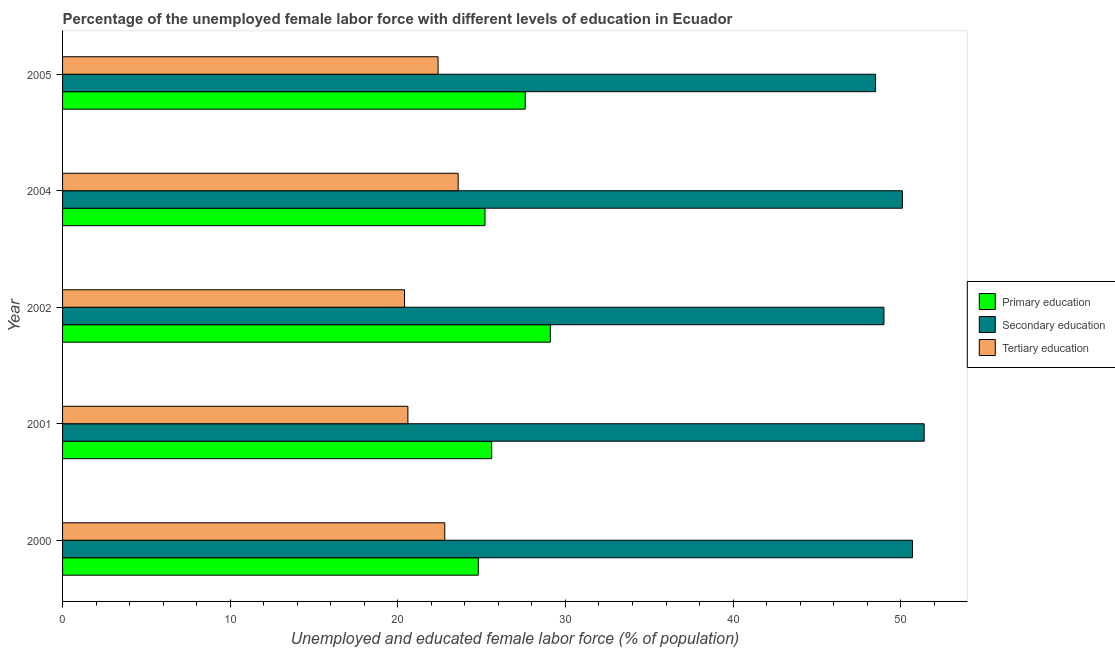How many groups of bars are there?
Offer a terse response. 5. Are the number of bars on each tick of the Y-axis equal?
Make the answer very short. Yes. What is the label of the 4th group of bars from the top?
Make the answer very short. 2001. What is the percentage of female labor force who received secondary education in 2005?
Offer a terse response. 48.5. Across all years, what is the maximum percentage of female labor force who received secondary education?
Give a very brief answer. 51.4. Across all years, what is the minimum percentage of female labor force who received primary education?
Keep it short and to the point. 24.8. In which year was the percentage of female labor force who received tertiary education minimum?
Give a very brief answer. 2002. What is the total percentage of female labor force who received primary education in the graph?
Provide a succinct answer. 132.3. What is the difference between the percentage of female labor force who received tertiary education in 2000 and the percentage of female labor force who received secondary education in 2005?
Offer a very short reply. -25.7. What is the average percentage of female labor force who received primary education per year?
Give a very brief answer. 26.46. In how many years, is the percentage of female labor force who received tertiary education greater than 28 %?
Your answer should be compact. 0. Is the percentage of female labor force who received tertiary education in 2000 less than that in 2002?
Offer a terse response. No. What is the difference between the highest and the second highest percentage of female labor force who received tertiary education?
Offer a terse response. 0.8. What is the difference between the highest and the lowest percentage of female labor force who received primary education?
Give a very brief answer. 4.3. Is the sum of the percentage of female labor force who received primary education in 2001 and 2005 greater than the maximum percentage of female labor force who received tertiary education across all years?
Offer a very short reply. Yes. What does the 3rd bar from the top in 2001 represents?
Keep it short and to the point. Primary education. What does the 2nd bar from the bottom in 2002 represents?
Your response must be concise. Secondary education. How many years are there in the graph?
Give a very brief answer. 5. What is the difference between two consecutive major ticks on the X-axis?
Offer a very short reply. 10. Are the values on the major ticks of X-axis written in scientific E-notation?
Your answer should be very brief. No. Does the graph contain any zero values?
Your answer should be compact. No. How are the legend labels stacked?
Your response must be concise. Vertical. What is the title of the graph?
Make the answer very short. Percentage of the unemployed female labor force with different levels of education in Ecuador. What is the label or title of the X-axis?
Give a very brief answer. Unemployed and educated female labor force (% of population). What is the Unemployed and educated female labor force (% of population) of Primary education in 2000?
Your response must be concise. 24.8. What is the Unemployed and educated female labor force (% of population) of Secondary education in 2000?
Make the answer very short. 50.7. What is the Unemployed and educated female labor force (% of population) of Tertiary education in 2000?
Give a very brief answer. 22.8. What is the Unemployed and educated female labor force (% of population) in Primary education in 2001?
Keep it short and to the point. 25.6. What is the Unemployed and educated female labor force (% of population) in Secondary education in 2001?
Give a very brief answer. 51.4. What is the Unemployed and educated female labor force (% of population) of Tertiary education in 2001?
Make the answer very short. 20.6. What is the Unemployed and educated female labor force (% of population) of Primary education in 2002?
Ensure brevity in your answer.  29.1. What is the Unemployed and educated female labor force (% of population) in Secondary education in 2002?
Provide a short and direct response. 49. What is the Unemployed and educated female labor force (% of population) of Tertiary education in 2002?
Provide a succinct answer. 20.4. What is the Unemployed and educated female labor force (% of population) of Primary education in 2004?
Your answer should be compact. 25.2. What is the Unemployed and educated female labor force (% of population) of Secondary education in 2004?
Your answer should be very brief. 50.1. What is the Unemployed and educated female labor force (% of population) of Tertiary education in 2004?
Make the answer very short. 23.6. What is the Unemployed and educated female labor force (% of population) of Primary education in 2005?
Offer a terse response. 27.6. What is the Unemployed and educated female labor force (% of population) in Secondary education in 2005?
Your answer should be compact. 48.5. What is the Unemployed and educated female labor force (% of population) in Tertiary education in 2005?
Provide a short and direct response. 22.4. Across all years, what is the maximum Unemployed and educated female labor force (% of population) in Primary education?
Keep it short and to the point. 29.1. Across all years, what is the maximum Unemployed and educated female labor force (% of population) in Secondary education?
Provide a short and direct response. 51.4. Across all years, what is the maximum Unemployed and educated female labor force (% of population) in Tertiary education?
Your response must be concise. 23.6. Across all years, what is the minimum Unemployed and educated female labor force (% of population) in Primary education?
Make the answer very short. 24.8. Across all years, what is the minimum Unemployed and educated female labor force (% of population) in Secondary education?
Provide a short and direct response. 48.5. Across all years, what is the minimum Unemployed and educated female labor force (% of population) of Tertiary education?
Your response must be concise. 20.4. What is the total Unemployed and educated female labor force (% of population) of Primary education in the graph?
Your answer should be very brief. 132.3. What is the total Unemployed and educated female labor force (% of population) of Secondary education in the graph?
Make the answer very short. 249.7. What is the total Unemployed and educated female labor force (% of population) of Tertiary education in the graph?
Offer a terse response. 109.8. What is the difference between the Unemployed and educated female labor force (% of population) in Primary education in 2000 and that in 2001?
Your answer should be compact. -0.8. What is the difference between the Unemployed and educated female labor force (% of population) of Tertiary education in 2000 and that in 2001?
Keep it short and to the point. 2.2. What is the difference between the Unemployed and educated female labor force (% of population) of Primary education in 2000 and that in 2002?
Your response must be concise. -4.3. What is the difference between the Unemployed and educated female labor force (% of population) of Secondary education in 2000 and that in 2004?
Give a very brief answer. 0.6. What is the difference between the Unemployed and educated female labor force (% of population) in Primary education in 2000 and that in 2005?
Give a very brief answer. -2.8. What is the difference between the Unemployed and educated female labor force (% of population) of Secondary education in 2000 and that in 2005?
Offer a terse response. 2.2. What is the difference between the Unemployed and educated female labor force (% of population) in Primary education in 2001 and that in 2002?
Offer a very short reply. -3.5. What is the difference between the Unemployed and educated female labor force (% of population) in Secondary education in 2001 and that in 2002?
Give a very brief answer. 2.4. What is the difference between the Unemployed and educated female labor force (% of population) of Tertiary education in 2001 and that in 2002?
Ensure brevity in your answer.  0.2. What is the difference between the Unemployed and educated female labor force (% of population) of Primary education in 2001 and that in 2004?
Your answer should be very brief. 0.4. What is the difference between the Unemployed and educated female labor force (% of population) in Secondary education in 2001 and that in 2004?
Provide a short and direct response. 1.3. What is the difference between the Unemployed and educated female labor force (% of population) in Primary education in 2001 and that in 2005?
Keep it short and to the point. -2. What is the difference between the Unemployed and educated female labor force (% of population) in Secondary education in 2001 and that in 2005?
Keep it short and to the point. 2.9. What is the difference between the Unemployed and educated female labor force (% of population) of Primary education in 2002 and that in 2004?
Your answer should be compact. 3.9. What is the difference between the Unemployed and educated female labor force (% of population) in Primary education in 2002 and that in 2005?
Provide a short and direct response. 1.5. What is the difference between the Unemployed and educated female labor force (% of population) of Secondary education in 2002 and that in 2005?
Give a very brief answer. 0.5. What is the difference between the Unemployed and educated female labor force (% of population) of Tertiary education in 2002 and that in 2005?
Offer a very short reply. -2. What is the difference between the Unemployed and educated female labor force (% of population) in Tertiary education in 2004 and that in 2005?
Give a very brief answer. 1.2. What is the difference between the Unemployed and educated female labor force (% of population) in Primary education in 2000 and the Unemployed and educated female labor force (% of population) in Secondary education in 2001?
Your answer should be very brief. -26.6. What is the difference between the Unemployed and educated female labor force (% of population) of Secondary education in 2000 and the Unemployed and educated female labor force (% of population) of Tertiary education in 2001?
Give a very brief answer. 30.1. What is the difference between the Unemployed and educated female labor force (% of population) in Primary education in 2000 and the Unemployed and educated female labor force (% of population) in Secondary education in 2002?
Your response must be concise. -24.2. What is the difference between the Unemployed and educated female labor force (% of population) in Primary education in 2000 and the Unemployed and educated female labor force (% of population) in Tertiary education in 2002?
Provide a succinct answer. 4.4. What is the difference between the Unemployed and educated female labor force (% of population) in Secondary education in 2000 and the Unemployed and educated female labor force (% of population) in Tertiary education in 2002?
Offer a very short reply. 30.3. What is the difference between the Unemployed and educated female labor force (% of population) in Primary education in 2000 and the Unemployed and educated female labor force (% of population) in Secondary education in 2004?
Offer a terse response. -25.3. What is the difference between the Unemployed and educated female labor force (% of population) in Secondary education in 2000 and the Unemployed and educated female labor force (% of population) in Tertiary education in 2004?
Your answer should be very brief. 27.1. What is the difference between the Unemployed and educated female labor force (% of population) of Primary education in 2000 and the Unemployed and educated female labor force (% of population) of Secondary education in 2005?
Offer a very short reply. -23.7. What is the difference between the Unemployed and educated female labor force (% of population) of Primary education in 2000 and the Unemployed and educated female labor force (% of population) of Tertiary education in 2005?
Give a very brief answer. 2.4. What is the difference between the Unemployed and educated female labor force (% of population) of Secondary education in 2000 and the Unemployed and educated female labor force (% of population) of Tertiary education in 2005?
Your answer should be compact. 28.3. What is the difference between the Unemployed and educated female labor force (% of population) in Primary education in 2001 and the Unemployed and educated female labor force (% of population) in Secondary education in 2002?
Provide a succinct answer. -23.4. What is the difference between the Unemployed and educated female labor force (% of population) of Primary education in 2001 and the Unemployed and educated female labor force (% of population) of Secondary education in 2004?
Keep it short and to the point. -24.5. What is the difference between the Unemployed and educated female labor force (% of population) in Secondary education in 2001 and the Unemployed and educated female labor force (% of population) in Tertiary education in 2004?
Your answer should be compact. 27.8. What is the difference between the Unemployed and educated female labor force (% of population) of Primary education in 2001 and the Unemployed and educated female labor force (% of population) of Secondary education in 2005?
Keep it short and to the point. -22.9. What is the difference between the Unemployed and educated female labor force (% of population) in Secondary education in 2001 and the Unemployed and educated female labor force (% of population) in Tertiary education in 2005?
Ensure brevity in your answer.  29. What is the difference between the Unemployed and educated female labor force (% of population) of Primary education in 2002 and the Unemployed and educated female labor force (% of population) of Secondary education in 2004?
Your response must be concise. -21. What is the difference between the Unemployed and educated female labor force (% of population) of Primary education in 2002 and the Unemployed and educated female labor force (% of population) of Tertiary education in 2004?
Your answer should be very brief. 5.5. What is the difference between the Unemployed and educated female labor force (% of population) in Secondary education in 2002 and the Unemployed and educated female labor force (% of population) in Tertiary education in 2004?
Offer a very short reply. 25.4. What is the difference between the Unemployed and educated female labor force (% of population) in Primary education in 2002 and the Unemployed and educated female labor force (% of population) in Secondary education in 2005?
Keep it short and to the point. -19.4. What is the difference between the Unemployed and educated female labor force (% of population) of Primary education in 2002 and the Unemployed and educated female labor force (% of population) of Tertiary education in 2005?
Provide a short and direct response. 6.7. What is the difference between the Unemployed and educated female labor force (% of population) of Secondary education in 2002 and the Unemployed and educated female labor force (% of population) of Tertiary education in 2005?
Your answer should be very brief. 26.6. What is the difference between the Unemployed and educated female labor force (% of population) in Primary education in 2004 and the Unemployed and educated female labor force (% of population) in Secondary education in 2005?
Provide a succinct answer. -23.3. What is the difference between the Unemployed and educated female labor force (% of population) of Primary education in 2004 and the Unemployed and educated female labor force (% of population) of Tertiary education in 2005?
Offer a terse response. 2.8. What is the difference between the Unemployed and educated female labor force (% of population) in Secondary education in 2004 and the Unemployed and educated female labor force (% of population) in Tertiary education in 2005?
Make the answer very short. 27.7. What is the average Unemployed and educated female labor force (% of population) of Primary education per year?
Your answer should be compact. 26.46. What is the average Unemployed and educated female labor force (% of population) in Secondary education per year?
Offer a very short reply. 49.94. What is the average Unemployed and educated female labor force (% of population) in Tertiary education per year?
Provide a short and direct response. 21.96. In the year 2000, what is the difference between the Unemployed and educated female labor force (% of population) in Primary education and Unemployed and educated female labor force (% of population) in Secondary education?
Your answer should be compact. -25.9. In the year 2000, what is the difference between the Unemployed and educated female labor force (% of population) of Secondary education and Unemployed and educated female labor force (% of population) of Tertiary education?
Provide a succinct answer. 27.9. In the year 2001, what is the difference between the Unemployed and educated female labor force (% of population) in Primary education and Unemployed and educated female labor force (% of population) in Secondary education?
Provide a short and direct response. -25.8. In the year 2001, what is the difference between the Unemployed and educated female labor force (% of population) in Secondary education and Unemployed and educated female labor force (% of population) in Tertiary education?
Your answer should be compact. 30.8. In the year 2002, what is the difference between the Unemployed and educated female labor force (% of population) in Primary education and Unemployed and educated female labor force (% of population) in Secondary education?
Your answer should be very brief. -19.9. In the year 2002, what is the difference between the Unemployed and educated female labor force (% of population) in Primary education and Unemployed and educated female labor force (% of population) in Tertiary education?
Keep it short and to the point. 8.7. In the year 2002, what is the difference between the Unemployed and educated female labor force (% of population) of Secondary education and Unemployed and educated female labor force (% of population) of Tertiary education?
Provide a succinct answer. 28.6. In the year 2004, what is the difference between the Unemployed and educated female labor force (% of population) in Primary education and Unemployed and educated female labor force (% of population) in Secondary education?
Ensure brevity in your answer.  -24.9. In the year 2004, what is the difference between the Unemployed and educated female labor force (% of population) in Primary education and Unemployed and educated female labor force (% of population) in Tertiary education?
Your answer should be compact. 1.6. In the year 2005, what is the difference between the Unemployed and educated female labor force (% of population) of Primary education and Unemployed and educated female labor force (% of population) of Secondary education?
Give a very brief answer. -20.9. In the year 2005, what is the difference between the Unemployed and educated female labor force (% of population) in Primary education and Unemployed and educated female labor force (% of population) in Tertiary education?
Provide a short and direct response. 5.2. In the year 2005, what is the difference between the Unemployed and educated female labor force (% of population) of Secondary education and Unemployed and educated female labor force (% of population) of Tertiary education?
Your response must be concise. 26.1. What is the ratio of the Unemployed and educated female labor force (% of population) in Primary education in 2000 to that in 2001?
Offer a very short reply. 0.97. What is the ratio of the Unemployed and educated female labor force (% of population) in Secondary education in 2000 to that in 2001?
Provide a short and direct response. 0.99. What is the ratio of the Unemployed and educated female labor force (% of population) of Tertiary education in 2000 to that in 2001?
Your answer should be compact. 1.11. What is the ratio of the Unemployed and educated female labor force (% of population) of Primary education in 2000 to that in 2002?
Offer a very short reply. 0.85. What is the ratio of the Unemployed and educated female labor force (% of population) in Secondary education in 2000 to that in 2002?
Ensure brevity in your answer.  1.03. What is the ratio of the Unemployed and educated female labor force (% of population) of Tertiary education in 2000 to that in 2002?
Provide a short and direct response. 1.12. What is the ratio of the Unemployed and educated female labor force (% of population) in Primary education in 2000 to that in 2004?
Offer a terse response. 0.98. What is the ratio of the Unemployed and educated female labor force (% of population) of Secondary education in 2000 to that in 2004?
Your answer should be very brief. 1.01. What is the ratio of the Unemployed and educated female labor force (% of population) of Tertiary education in 2000 to that in 2004?
Your answer should be very brief. 0.97. What is the ratio of the Unemployed and educated female labor force (% of population) of Primary education in 2000 to that in 2005?
Your response must be concise. 0.9. What is the ratio of the Unemployed and educated female labor force (% of population) in Secondary education in 2000 to that in 2005?
Your response must be concise. 1.05. What is the ratio of the Unemployed and educated female labor force (% of population) of Tertiary education in 2000 to that in 2005?
Your answer should be compact. 1.02. What is the ratio of the Unemployed and educated female labor force (% of population) of Primary education in 2001 to that in 2002?
Your response must be concise. 0.88. What is the ratio of the Unemployed and educated female labor force (% of population) in Secondary education in 2001 to that in 2002?
Keep it short and to the point. 1.05. What is the ratio of the Unemployed and educated female labor force (% of population) of Tertiary education in 2001 to that in 2002?
Your response must be concise. 1.01. What is the ratio of the Unemployed and educated female labor force (% of population) in Primary education in 2001 to that in 2004?
Offer a very short reply. 1.02. What is the ratio of the Unemployed and educated female labor force (% of population) in Secondary education in 2001 to that in 2004?
Your response must be concise. 1.03. What is the ratio of the Unemployed and educated female labor force (% of population) of Tertiary education in 2001 to that in 2004?
Give a very brief answer. 0.87. What is the ratio of the Unemployed and educated female labor force (% of population) of Primary education in 2001 to that in 2005?
Offer a very short reply. 0.93. What is the ratio of the Unemployed and educated female labor force (% of population) of Secondary education in 2001 to that in 2005?
Provide a succinct answer. 1.06. What is the ratio of the Unemployed and educated female labor force (% of population) of Tertiary education in 2001 to that in 2005?
Ensure brevity in your answer.  0.92. What is the ratio of the Unemployed and educated female labor force (% of population) of Primary education in 2002 to that in 2004?
Provide a succinct answer. 1.15. What is the ratio of the Unemployed and educated female labor force (% of population) of Tertiary education in 2002 to that in 2004?
Your response must be concise. 0.86. What is the ratio of the Unemployed and educated female labor force (% of population) of Primary education in 2002 to that in 2005?
Give a very brief answer. 1.05. What is the ratio of the Unemployed and educated female labor force (% of population) of Secondary education in 2002 to that in 2005?
Your answer should be very brief. 1.01. What is the ratio of the Unemployed and educated female labor force (% of population) in Tertiary education in 2002 to that in 2005?
Ensure brevity in your answer.  0.91. What is the ratio of the Unemployed and educated female labor force (% of population) in Primary education in 2004 to that in 2005?
Give a very brief answer. 0.91. What is the ratio of the Unemployed and educated female labor force (% of population) in Secondary education in 2004 to that in 2005?
Provide a short and direct response. 1.03. What is the ratio of the Unemployed and educated female labor force (% of population) of Tertiary education in 2004 to that in 2005?
Provide a short and direct response. 1.05. What is the difference between the highest and the second highest Unemployed and educated female labor force (% of population) of Tertiary education?
Your response must be concise. 0.8. What is the difference between the highest and the lowest Unemployed and educated female labor force (% of population) of Tertiary education?
Offer a very short reply. 3.2. 